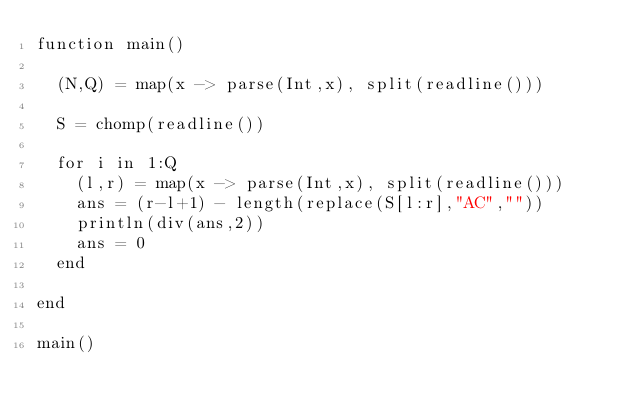Convert code to text. <code><loc_0><loc_0><loc_500><loc_500><_Julia_>function main()
  
  (N,Q) = map(x -> parse(Int,x), split(readline()))
  
  S = chomp(readline())
  
  for i in 1:Q
    (l,r) = map(x -> parse(Int,x), split(readline()))
    ans = (r-l+1) - length(replace(S[l:r],"AC",""))
    println(div(ans,2))
    ans = 0
  end
  
end

main()</code> 